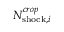<formula> <loc_0><loc_0><loc_500><loc_500>N _ { { s h o c k } , i } ^ { c r o p }</formula> 